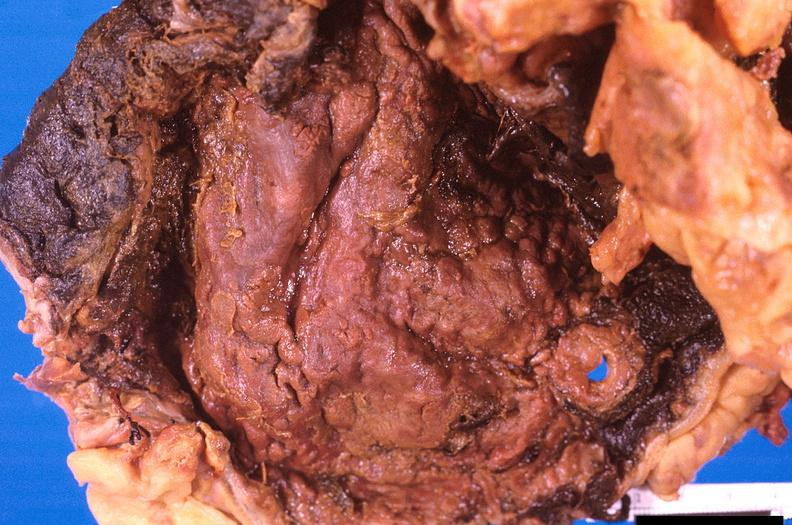does papillary adenoma show stomach, necrotizing esophagitis and gastritis, sulfuric acid ingested as suicide attempt?
Answer the question using a single word or phrase. No 